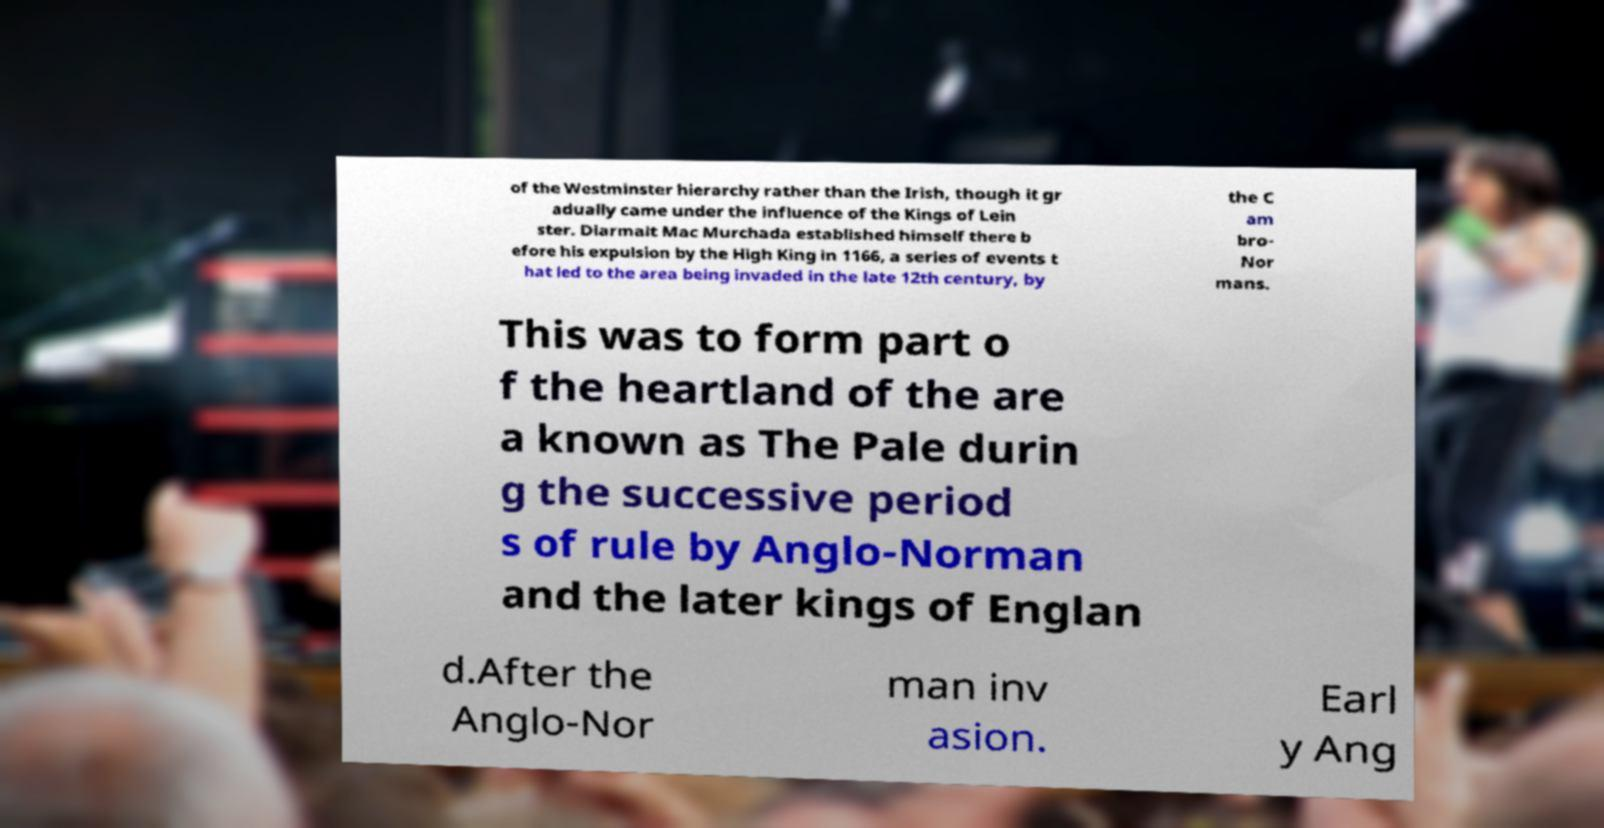For documentation purposes, I need the text within this image transcribed. Could you provide that? of the Westminster hierarchy rather than the Irish, though it gr adually came under the influence of the Kings of Lein ster. Diarmait Mac Murchada established himself there b efore his expulsion by the High King in 1166, a series of events t hat led to the area being invaded in the late 12th century, by the C am bro- Nor mans. This was to form part o f the heartland of the are a known as The Pale durin g the successive period s of rule by Anglo-Norman and the later kings of Englan d.After the Anglo-Nor man inv asion. Earl y Ang 